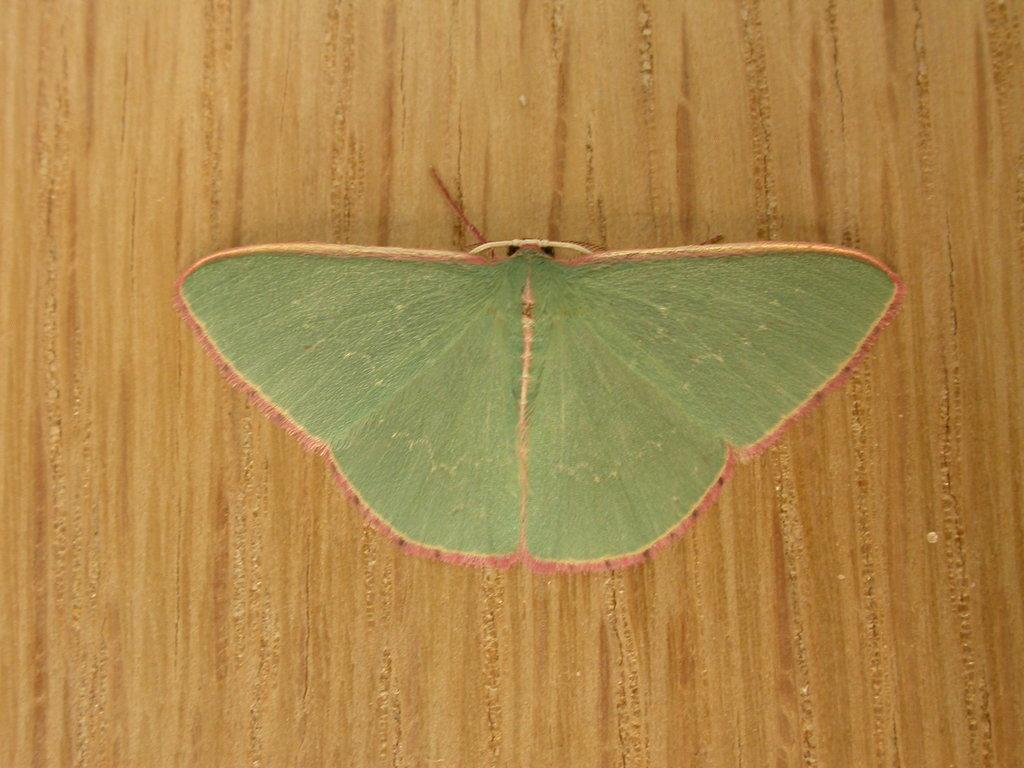What is the main subject of the image? There is a butterfly in the image. What type of surface is the butterfly on? The butterfly is on a wooden surface. What type of scissors can be seen cutting the agreement in the image? There are no scissors or agreements present in the image; it features a butterfly on a wooden surface. 